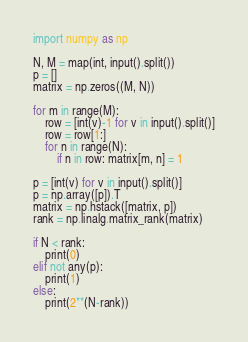<code> <loc_0><loc_0><loc_500><loc_500><_Python_>import numpy as np

N, M = map(int, input().split())
p = []
matrix = np.zeros((M, N))

for m in range(M):
    row = [int(v)-1 for v in input().split()]
    row = row[1:]
    for n in range(N):
        if n in row: matrix[m, n] = 1

p = [int(v) for v in input().split()]
p = np.array([p]).T
matrix = np.hstack([matrix, p])
rank = np.linalg.matrix_rank(matrix)

if N < rank:
    print(0)
elif not any(p):
    print(1)
else:
    print(2**(N-rank))

</code> 